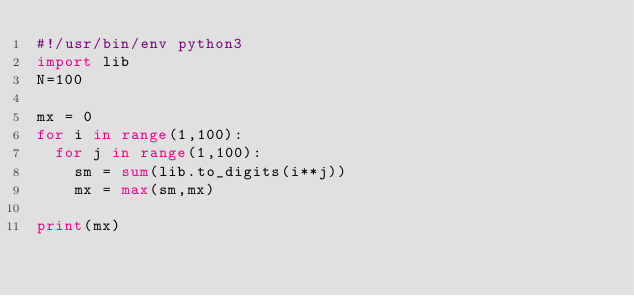<code> <loc_0><loc_0><loc_500><loc_500><_Python_>#!/usr/bin/env python3
import lib
N=100

mx = 0
for i in range(1,100):
  for j in range(1,100):
    sm = sum(lib.to_digits(i**j))
    mx = max(sm,mx)

print(mx)</code> 